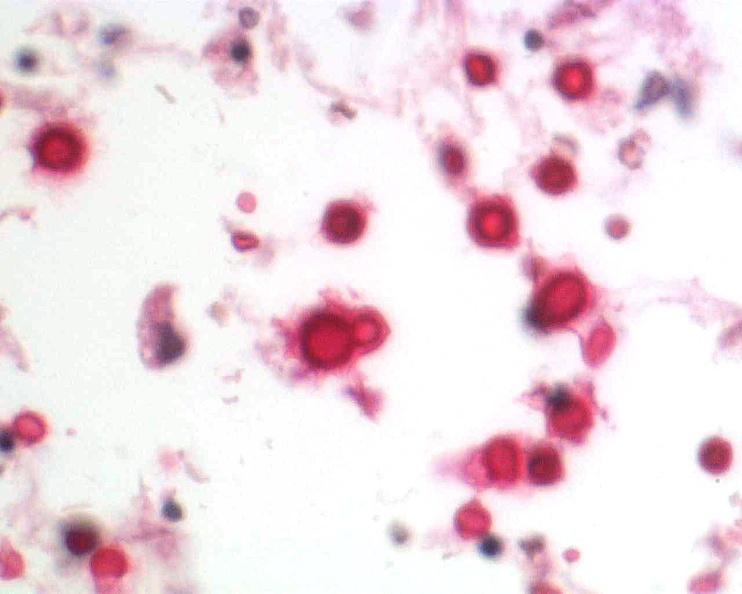does subdiaphragmatic abscess show brain, cryptococcal meningitis?
Answer the question using a single word or phrase. No 